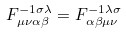<formula> <loc_0><loc_0><loc_500><loc_500>F ^ { - 1 \sigma \lambda } _ { \mu \nu \alpha \beta } = F ^ { - 1 \lambda \sigma } _ { \alpha \beta \mu \nu }</formula> 